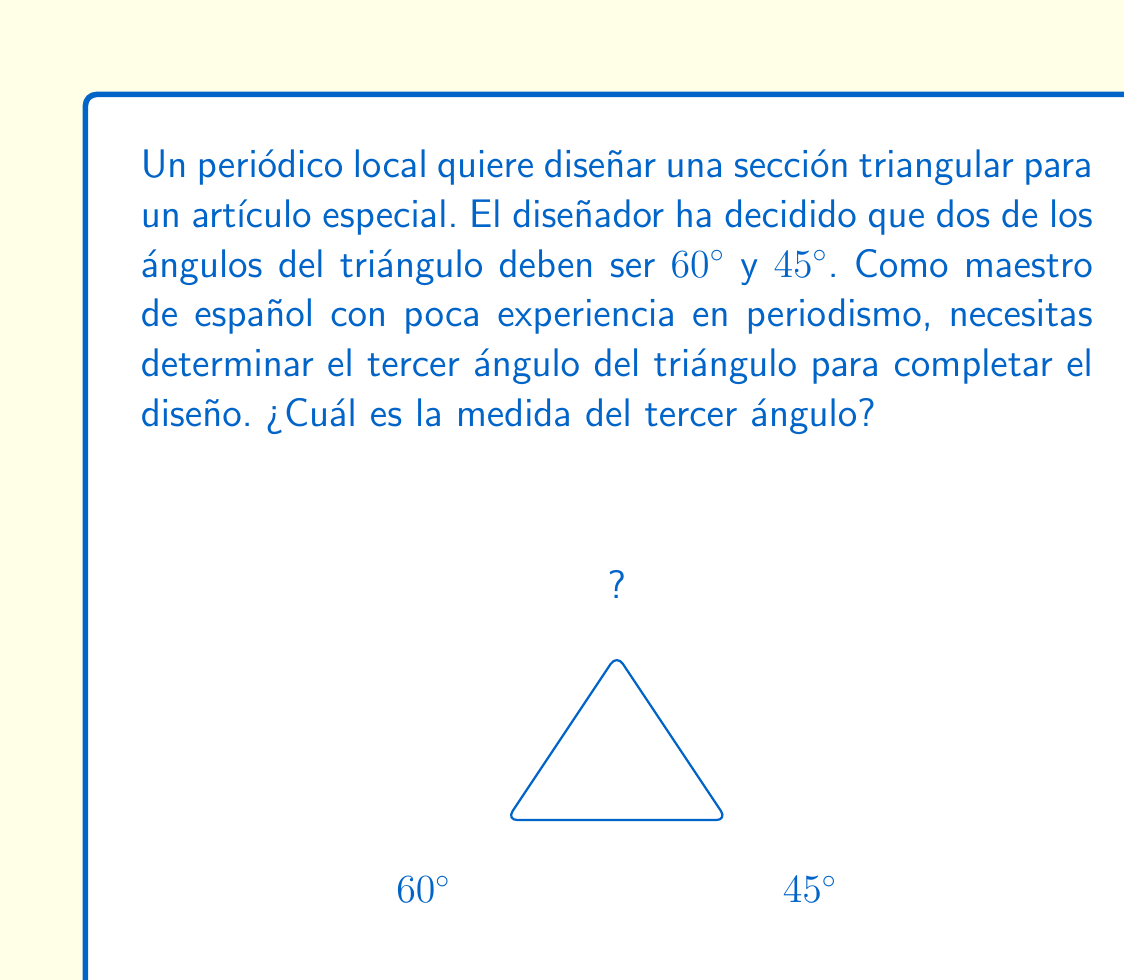Give your solution to this math problem. Para resolver este problema, utilizaremos el teorema de la suma de los ángulos internos de un triángulo. Este teorema establece que la suma de los ángulos internos de cualquier triángulo es siempre 180°.

Pasos para la solución:

1. Recordemos el teorema: $\text{Ángulo 1} + \text{Ángulo 2} + \text{Ángulo 3} = 180°$

2. Tenemos dos ángulos conocidos:
   - Ángulo 1 = $60°$
   - Ángulo 2 = $45°$

3. Llamemos al tercer ángulo desconocido $x$. Podemos establecer la ecuación:

   $60° + 45° + x = 180°$

4. Simplificamos:
   
   $105° + x = 180°$

5. Restamos 105° de ambos lados:

   $x = 180° - 105°$

6. Calculamos:

   $x = 75°$

Por lo tanto, el tercer ángulo del triángulo mide 75°.
Answer: El tercer ángulo del triángulo mide $75°$. 